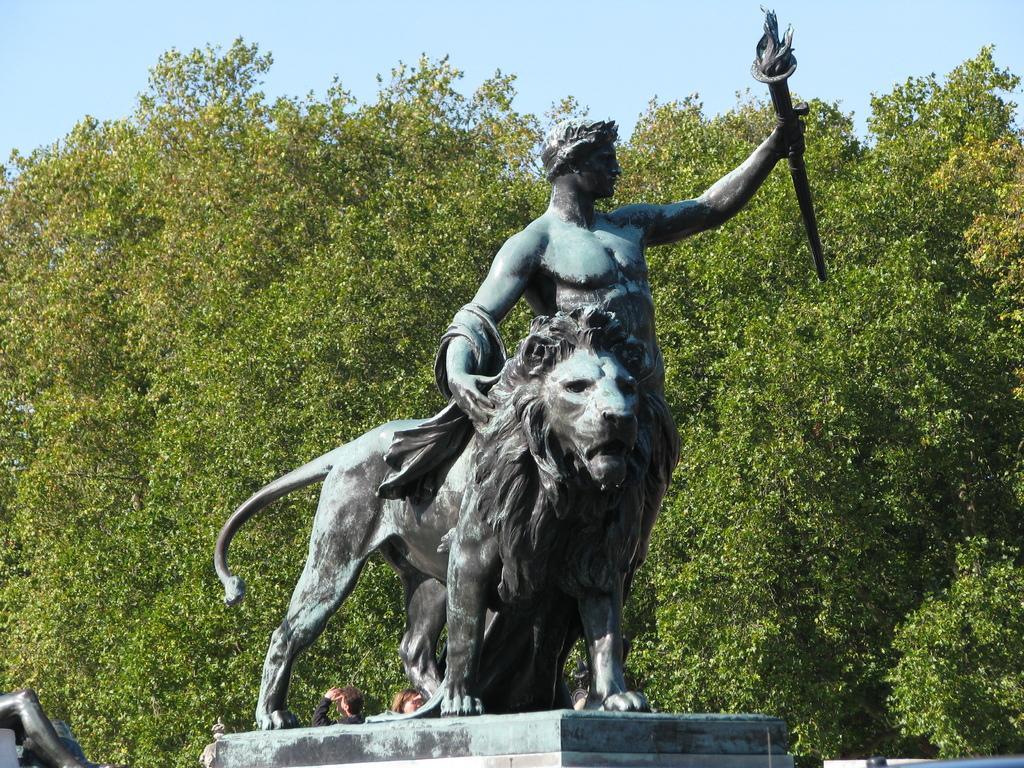Can you describe this image briefly? In the center of the image a sculpture is there. In the background of the image trees are present. At the top of the image sky is there. 